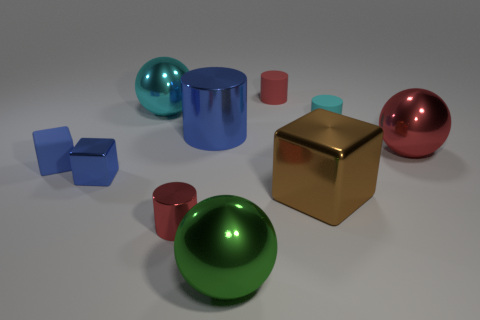How many small blue rubber objects are the same shape as the green metal object?
Give a very brief answer. 0. Are there the same number of large objects that are right of the brown shiny block and shiny cylinders to the right of the large green shiny sphere?
Give a very brief answer. No. Are any purple matte balls visible?
Provide a succinct answer. No. There is a red object that is behind the metallic sphere left of the cylinder in front of the brown block; how big is it?
Keep it short and to the point. Small. What is the shape of the green thing that is the same size as the cyan metal object?
Offer a terse response. Sphere. Is there anything else that has the same material as the large blue cylinder?
Provide a succinct answer. Yes. What number of objects are either metallic things to the left of the large blue shiny thing or small blue cubes?
Provide a short and direct response. 4. Is there a small red rubber cylinder in front of the red cylinder behind the tiny cyan matte object that is in front of the cyan sphere?
Your answer should be compact. No. What number of spheres are there?
Provide a succinct answer. 3. How many objects are small rubber cylinders that are behind the cyan ball or shiny cylinders that are in front of the blue cylinder?
Ensure brevity in your answer.  2. 